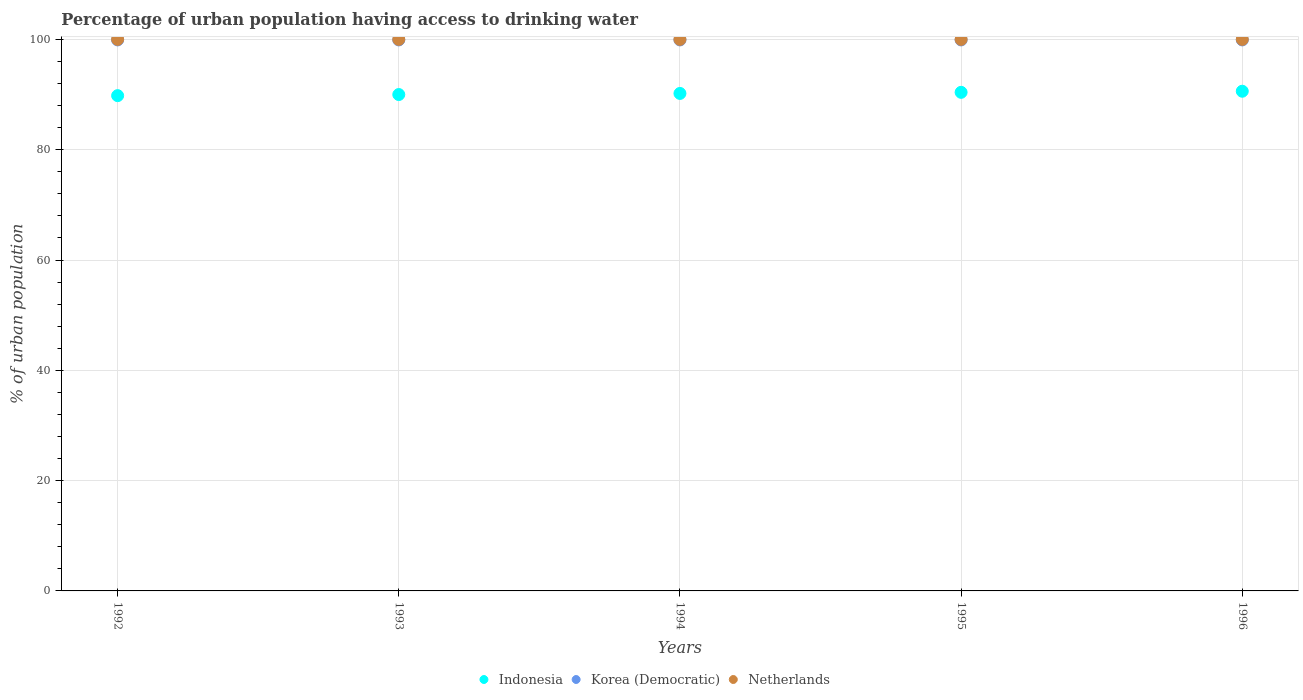What is the percentage of urban population having access to drinking water in Indonesia in 1994?
Offer a terse response. 90.2. Across all years, what is the maximum percentage of urban population having access to drinking water in Netherlands?
Ensure brevity in your answer.  100. Across all years, what is the minimum percentage of urban population having access to drinking water in Indonesia?
Give a very brief answer. 89.8. In which year was the percentage of urban population having access to drinking water in Indonesia maximum?
Your answer should be very brief. 1996. In which year was the percentage of urban population having access to drinking water in Indonesia minimum?
Ensure brevity in your answer.  1992. What is the total percentage of urban population having access to drinking water in Indonesia in the graph?
Provide a short and direct response. 451. What is the difference between the percentage of urban population having access to drinking water in Netherlands in 1993 and the percentage of urban population having access to drinking water in Korea (Democratic) in 1992?
Ensure brevity in your answer.  0.1. What is the average percentage of urban population having access to drinking water in Netherlands per year?
Keep it short and to the point. 100. In the year 1995, what is the difference between the percentage of urban population having access to drinking water in Indonesia and percentage of urban population having access to drinking water in Korea (Democratic)?
Give a very brief answer. -9.5. What is the ratio of the percentage of urban population having access to drinking water in Indonesia in 1993 to that in 1995?
Offer a very short reply. 1. What is the difference between the highest and the second highest percentage of urban population having access to drinking water in Korea (Democratic)?
Make the answer very short. 0. In how many years, is the percentage of urban population having access to drinking water in Netherlands greater than the average percentage of urban population having access to drinking water in Netherlands taken over all years?
Ensure brevity in your answer.  0. Is it the case that in every year, the sum of the percentage of urban population having access to drinking water in Indonesia and percentage of urban population having access to drinking water in Korea (Democratic)  is greater than the percentage of urban population having access to drinking water in Netherlands?
Your answer should be compact. Yes. Does the percentage of urban population having access to drinking water in Indonesia monotonically increase over the years?
Your answer should be very brief. Yes. How many dotlines are there?
Make the answer very short. 3. Are the values on the major ticks of Y-axis written in scientific E-notation?
Keep it short and to the point. No. How many legend labels are there?
Ensure brevity in your answer.  3. What is the title of the graph?
Your answer should be compact. Percentage of urban population having access to drinking water. Does "Djibouti" appear as one of the legend labels in the graph?
Make the answer very short. No. What is the label or title of the X-axis?
Offer a very short reply. Years. What is the label or title of the Y-axis?
Give a very brief answer. % of urban population. What is the % of urban population in Indonesia in 1992?
Provide a short and direct response. 89.8. What is the % of urban population in Korea (Democratic) in 1992?
Provide a succinct answer. 99.9. What is the % of urban population in Netherlands in 1992?
Provide a succinct answer. 100. What is the % of urban population of Indonesia in 1993?
Your answer should be very brief. 90. What is the % of urban population of Korea (Democratic) in 1993?
Offer a terse response. 99.9. What is the % of urban population of Netherlands in 1993?
Offer a very short reply. 100. What is the % of urban population in Indonesia in 1994?
Make the answer very short. 90.2. What is the % of urban population in Korea (Democratic) in 1994?
Offer a very short reply. 99.9. What is the % of urban population in Indonesia in 1995?
Ensure brevity in your answer.  90.4. What is the % of urban population of Korea (Democratic) in 1995?
Your response must be concise. 99.9. What is the % of urban population of Indonesia in 1996?
Your answer should be compact. 90.6. What is the % of urban population of Korea (Democratic) in 1996?
Give a very brief answer. 99.9. Across all years, what is the maximum % of urban population of Indonesia?
Ensure brevity in your answer.  90.6. Across all years, what is the maximum % of urban population of Korea (Democratic)?
Make the answer very short. 99.9. Across all years, what is the minimum % of urban population in Indonesia?
Ensure brevity in your answer.  89.8. Across all years, what is the minimum % of urban population of Korea (Democratic)?
Make the answer very short. 99.9. Across all years, what is the minimum % of urban population in Netherlands?
Provide a succinct answer. 100. What is the total % of urban population of Indonesia in the graph?
Your answer should be very brief. 451. What is the total % of urban population in Korea (Democratic) in the graph?
Your response must be concise. 499.5. What is the difference between the % of urban population of Korea (Democratic) in 1992 and that in 1993?
Ensure brevity in your answer.  0. What is the difference between the % of urban population of Netherlands in 1992 and that in 1993?
Your answer should be very brief. 0. What is the difference between the % of urban population of Netherlands in 1992 and that in 1994?
Offer a terse response. 0. What is the difference between the % of urban population of Indonesia in 1992 and that in 1995?
Your answer should be compact. -0.6. What is the difference between the % of urban population in Korea (Democratic) in 1992 and that in 1995?
Offer a very short reply. 0. What is the difference between the % of urban population in Indonesia in 1992 and that in 1996?
Keep it short and to the point. -0.8. What is the difference between the % of urban population of Korea (Democratic) in 1993 and that in 1995?
Keep it short and to the point. 0. What is the difference between the % of urban population in Indonesia in 1993 and that in 1996?
Your answer should be very brief. -0.6. What is the difference between the % of urban population of Korea (Democratic) in 1993 and that in 1996?
Give a very brief answer. 0. What is the difference between the % of urban population of Indonesia in 1994 and that in 1996?
Your response must be concise. -0.4. What is the difference between the % of urban population of Korea (Democratic) in 1994 and that in 1996?
Ensure brevity in your answer.  0. What is the difference between the % of urban population in Korea (Democratic) in 1995 and that in 1996?
Keep it short and to the point. 0. What is the difference between the % of urban population of Netherlands in 1995 and that in 1996?
Provide a succinct answer. 0. What is the difference between the % of urban population in Indonesia in 1992 and the % of urban population in Korea (Democratic) in 1995?
Keep it short and to the point. -10.1. What is the difference between the % of urban population of Indonesia in 1992 and the % of urban population of Korea (Democratic) in 1996?
Offer a very short reply. -10.1. What is the difference between the % of urban population of Indonesia in 1993 and the % of urban population of Netherlands in 1994?
Provide a succinct answer. -10. What is the difference between the % of urban population in Korea (Democratic) in 1993 and the % of urban population in Netherlands in 1994?
Keep it short and to the point. -0.1. What is the difference between the % of urban population in Korea (Democratic) in 1993 and the % of urban population in Netherlands in 1995?
Give a very brief answer. -0.1. What is the difference between the % of urban population in Indonesia in 1993 and the % of urban population in Korea (Democratic) in 1996?
Keep it short and to the point. -9.9. What is the difference between the % of urban population of Indonesia in 1994 and the % of urban population of Netherlands in 1996?
Provide a succinct answer. -9.8. What is the difference between the % of urban population of Korea (Democratic) in 1994 and the % of urban population of Netherlands in 1996?
Make the answer very short. -0.1. What is the difference between the % of urban population in Indonesia in 1995 and the % of urban population in Netherlands in 1996?
Offer a very short reply. -9.6. What is the difference between the % of urban population of Korea (Democratic) in 1995 and the % of urban population of Netherlands in 1996?
Keep it short and to the point. -0.1. What is the average % of urban population of Indonesia per year?
Provide a short and direct response. 90.2. What is the average % of urban population of Korea (Democratic) per year?
Offer a terse response. 99.9. What is the average % of urban population of Netherlands per year?
Make the answer very short. 100. In the year 1992, what is the difference between the % of urban population in Indonesia and % of urban population in Korea (Democratic)?
Offer a very short reply. -10.1. In the year 1993, what is the difference between the % of urban population in Indonesia and % of urban population in Korea (Democratic)?
Your answer should be very brief. -9.9. In the year 1994, what is the difference between the % of urban population of Indonesia and % of urban population of Korea (Democratic)?
Make the answer very short. -9.7. In the year 1994, what is the difference between the % of urban population of Indonesia and % of urban population of Netherlands?
Offer a terse response. -9.8. In the year 1994, what is the difference between the % of urban population of Korea (Democratic) and % of urban population of Netherlands?
Your response must be concise. -0.1. In the year 1995, what is the difference between the % of urban population in Indonesia and % of urban population in Netherlands?
Offer a terse response. -9.6. In the year 1996, what is the difference between the % of urban population in Indonesia and % of urban population in Netherlands?
Provide a succinct answer. -9.4. In the year 1996, what is the difference between the % of urban population in Korea (Democratic) and % of urban population in Netherlands?
Your answer should be compact. -0.1. What is the ratio of the % of urban population of Indonesia in 1992 to that in 1993?
Offer a very short reply. 1. What is the ratio of the % of urban population in Korea (Democratic) in 1992 to that in 1993?
Ensure brevity in your answer.  1. What is the ratio of the % of urban population of Korea (Democratic) in 1992 to that in 1994?
Your answer should be compact. 1. What is the ratio of the % of urban population of Netherlands in 1992 to that in 1994?
Offer a very short reply. 1. What is the ratio of the % of urban population in Korea (Democratic) in 1992 to that in 1995?
Your answer should be very brief. 1. What is the ratio of the % of urban population of Netherlands in 1992 to that in 1996?
Your answer should be compact. 1. What is the ratio of the % of urban population in Indonesia in 1993 to that in 1994?
Ensure brevity in your answer.  1. What is the ratio of the % of urban population of Netherlands in 1993 to that in 1995?
Provide a short and direct response. 1. What is the ratio of the % of urban population in Korea (Democratic) in 1993 to that in 1996?
Keep it short and to the point. 1. What is the ratio of the % of urban population of Netherlands in 1993 to that in 1996?
Provide a succinct answer. 1. What is the ratio of the % of urban population in Korea (Democratic) in 1994 to that in 1995?
Provide a succinct answer. 1. What is the ratio of the % of urban population of Indonesia in 1994 to that in 1996?
Give a very brief answer. 1. What is the ratio of the % of urban population in Indonesia in 1995 to that in 1996?
Make the answer very short. 1. What is the ratio of the % of urban population in Korea (Democratic) in 1995 to that in 1996?
Your answer should be compact. 1. What is the difference between the highest and the second highest % of urban population of Indonesia?
Offer a terse response. 0.2. What is the difference between the highest and the second highest % of urban population of Korea (Democratic)?
Provide a short and direct response. 0. What is the difference between the highest and the second highest % of urban population of Netherlands?
Offer a terse response. 0. What is the difference between the highest and the lowest % of urban population in Indonesia?
Provide a succinct answer. 0.8. 